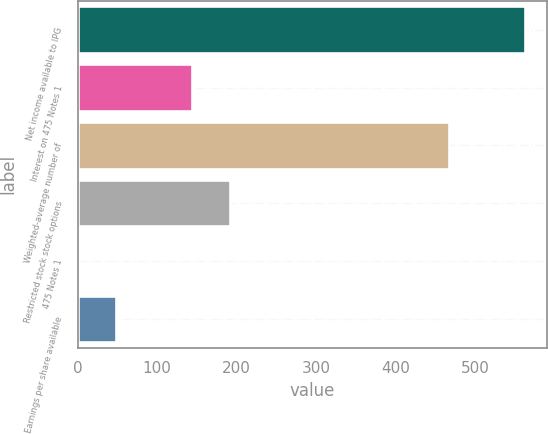<chart> <loc_0><loc_0><loc_500><loc_500><bar_chart><fcel>Net income available to IPG<fcel>Interest on 475 Notes 1<fcel>Weighted-average number of<fcel>Restricted stock stock options<fcel>475 Notes 1<fcel>Earnings per share available<nl><fcel>562<fcel>143.87<fcel>466.8<fcel>191.47<fcel>1.07<fcel>48.67<nl></chart> 